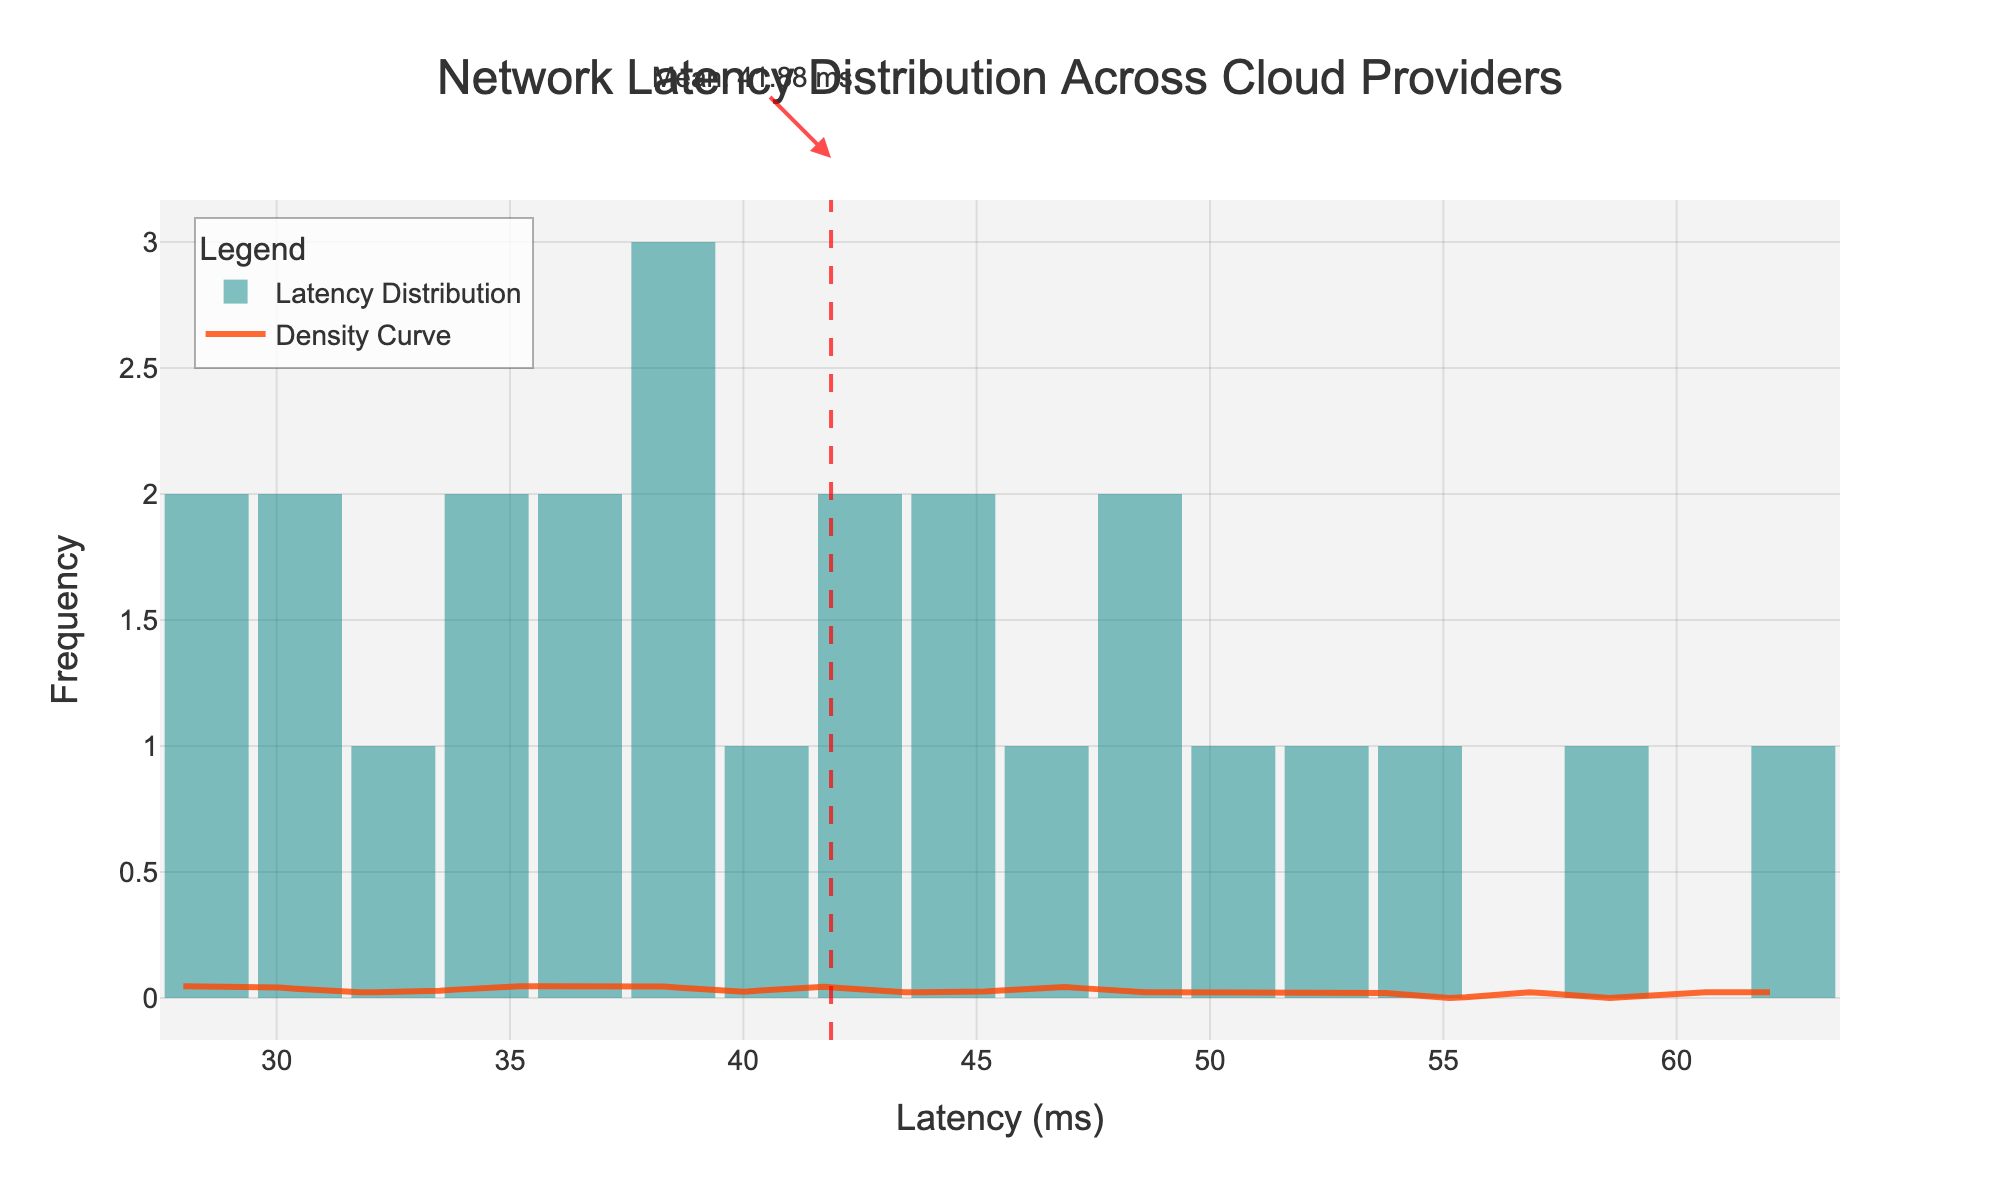What's the title of the figure? The title is clearly shown at the top center of the figure in a larger font size to highlight its importance.
Answer: Network Latency Distribution Across Cloud Providers What does the x-axis represent? The x-axis label is given beneath the axis and it indicates what the data points along the axis refer to.
Answer: Latency (ms) What does the y-axis represent? The y-axis label is given along the side and it indicates what the data points along the axis refer to.
Answer: Frequency Which color represents the histogram bars? The histogram bars are visually represented with a color fill that distinguishes them from other elements in the figure.
Answer: Teal What does the red dashed line signify? The red dashed line spans vertically across the figure indicating a specific statistical measure marked with an annotation on the figure.
Answer: Mean latency value What is the mean latency value? The mean value is annotated where the red dashed line intersects the x-axis, making it visible directly on the figure.
Answer: 42.24 ms Which part of the figure represents the density curve? The density curve is represented as a smooth line that overlays the histogram bars, shown prominently with a distinct color and legend label.
Answer: Orange line What range of latencies is most frequently observed in the figure? By examining the heights of the histogram bars, one can determine the range where the frequency is highest, which is indicated by taller bars.
Answer: 35-45 ms Is there a histogram bar higher than the others? If yes, what is its corresponding latency range? The histogram bar that is tallest among the others indicates the most frequent latency range. This is determined by comparing the height of each bar visually.
Answer: Yes, 35-40 ms Describe the overall shape of the density curve. The density curve shows a visual representation of the distribution of latency data. By examining the curve shape, one can understand how data is spread across different latency values.
Answer: Right-skewed 